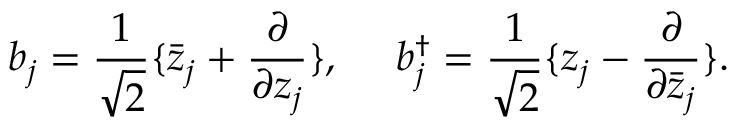Convert formula to latex. <formula><loc_0><loc_0><loc_500><loc_500>b _ { j } = { \frac { 1 } { \sqrt { 2 } } } \{ \bar { z } _ { j } + { \frac { \partial } { \partial z _ { j } } } \} , b _ { j } ^ { \dagger } = { \frac { 1 } { \sqrt { 2 } } } \{ z _ { j } - { \frac { \partial } { \partial \bar { z } _ { j } } } \} .</formula> 